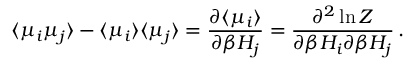<formula> <loc_0><loc_0><loc_500><loc_500>\langle \mu _ { i } \mu _ { j } \rangle - \langle \mu _ { i } \rangle \langle \mu _ { j } \rangle = \frac { \partial \langle \mu _ { i } \rangle } { \partial \beta H _ { j } } = \frac { \partial ^ { 2 } \ln Z } { \partial \beta H _ { i } \partial \beta H _ { j } } \, .</formula> 